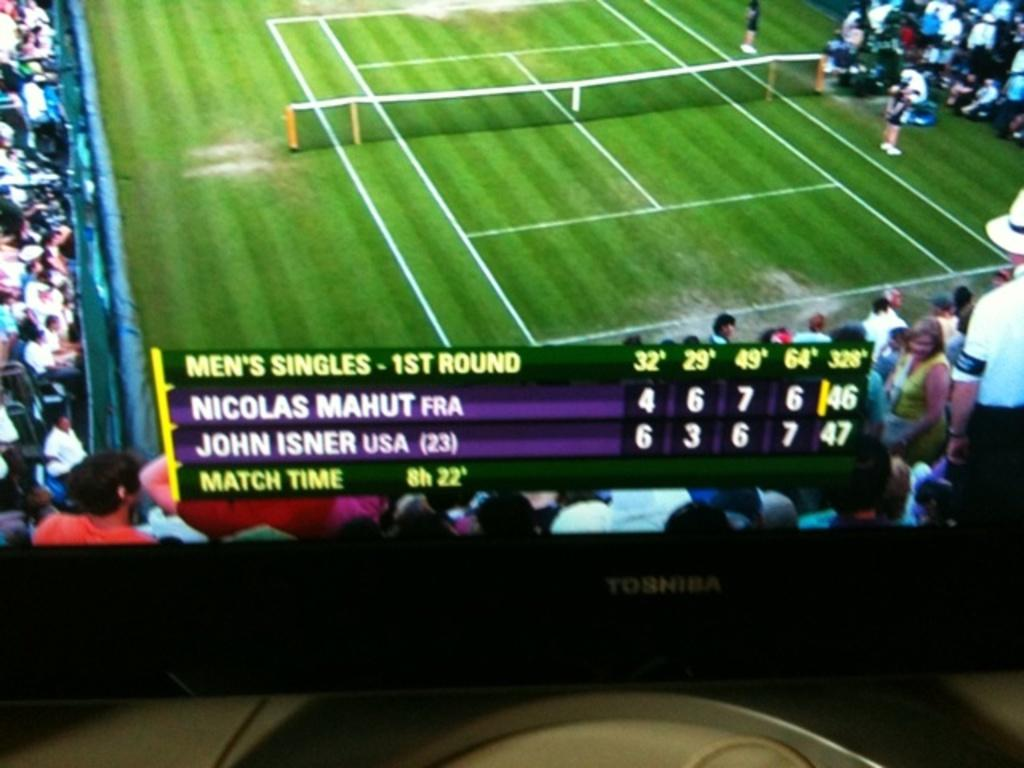<image>
Summarize the visual content of the image. a large screen showing the mens singles 1st round scores 